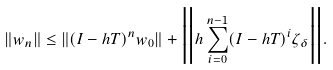<formula> <loc_0><loc_0><loc_500><loc_500>\| w _ { n } \| \leq \| ( I - h T ) ^ { n } w _ { 0 } \| + \Big { \| } h \sum _ { i = 0 } ^ { n - 1 } ( I - h T ) ^ { i } \zeta _ { \delta } \Big { \| } .</formula> 